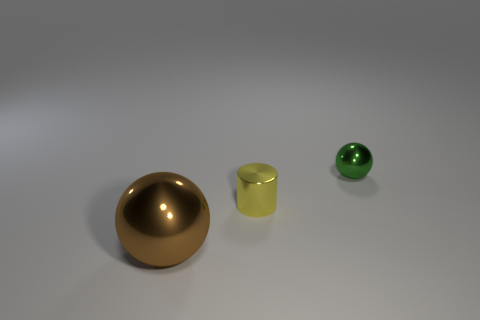Add 1 purple spheres. How many objects exist? 4 Subtract all cylinders. How many objects are left? 2 Add 3 tiny objects. How many tiny objects exist? 5 Subtract 0 red spheres. How many objects are left? 3 Subtract 1 balls. How many balls are left? 1 Subtract all blue cylinders. Subtract all yellow balls. How many cylinders are left? 1 Subtract all cyan balls. How many cyan cylinders are left? 0 Subtract all big purple balls. Subtract all shiny balls. How many objects are left? 1 Add 1 large brown metal spheres. How many large brown metal spheres are left? 2 